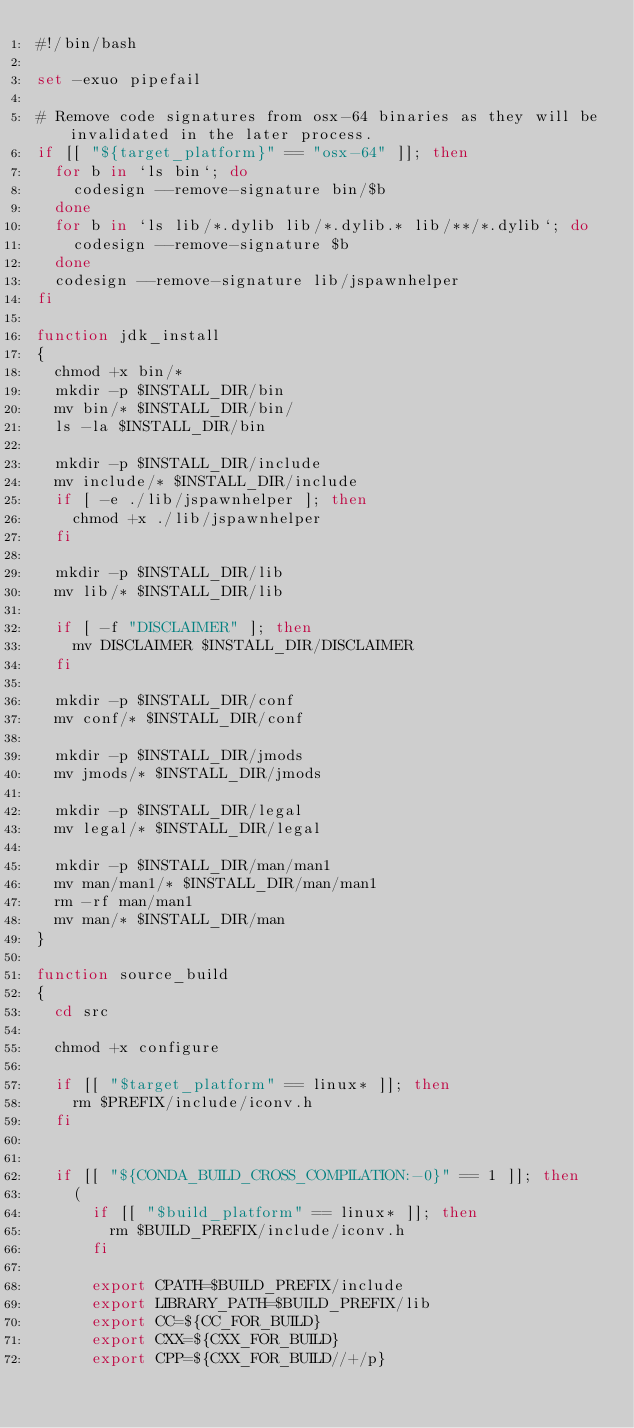<code> <loc_0><loc_0><loc_500><loc_500><_Bash_>#!/bin/bash

set -exuo pipefail

# Remove code signatures from osx-64 binaries as they will be invalidated in the later process.
if [[ "${target_platform}" == "osx-64" ]]; then
  for b in `ls bin`; do
    codesign --remove-signature bin/$b
  done
  for b in `ls lib/*.dylib lib/*.dylib.* lib/**/*.dylib`; do
    codesign --remove-signature $b
  done
  codesign --remove-signature lib/jspawnhelper
fi

function jdk_install
{
  chmod +x bin/*
  mkdir -p $INSTALL_DIR/bin
  mv bin/* $INSTALL_DIR/bin/
  ls -la $INSTALL_DIR/bin

  mkdir -p $INSTALL_DIR/include
  mv include/* $INSTALL_DIR/include
  if [ -e ./lib/jspawnhelper ]; then
    chmod +x ./lib/jspawnhelper
  fi

  mkdir -p $INSTALL_DIR/lib
  mv lib/* $INSTALL_DIR/lib

  if [ -f "DISCLAIMER" ]; then
    mv DISCLAIMER $INSTALL_DIR/DISCLAIMER
  fi

  mkdir -p $INSTALL_DIR/conf
  mv conf/* $INSTALL_DIR/conf

  mkdir -p $INSTALL_DIR/jmods
  mv jmods/* $INSTALL_DIR/jmods

  mkdir -p $INSTALL_DIR/legal
  mv legal/* $INSTALL_DIR/legal

  mkdir -p $INSTALL_DIR/man/man1
  mv man/man1/* $INSTALL_DIR/man/man1
  rm -rf man/man1
  mv man/* $INSTALL_DIR/man
}

function source_build
{
  cd src

  chmod +x configure

  if [[ "$target_platform" == linux* ]]; then
    rm $PREFIX/include/iconv.h
  fi


  if [[ "${CONDA_BUILD_CROSS_COMPILATION:-0}" == 1 ]]; then
    (
      if [[ "$build_platform" == linux* ]]; then
        rm $BUILD_PREFIX/include/iconv.h
      fi

      export CPATH=$BUILD_PREFIX/include
      export LIBRARY_PATH=$BUILD_PREFIX/lib
      export CC=${CC_FOR_BUILD}
      export CXX=${CXX_FOR_BUILD}
      export CPP=${CXX_FOR_BUILD//+/p}</code> 